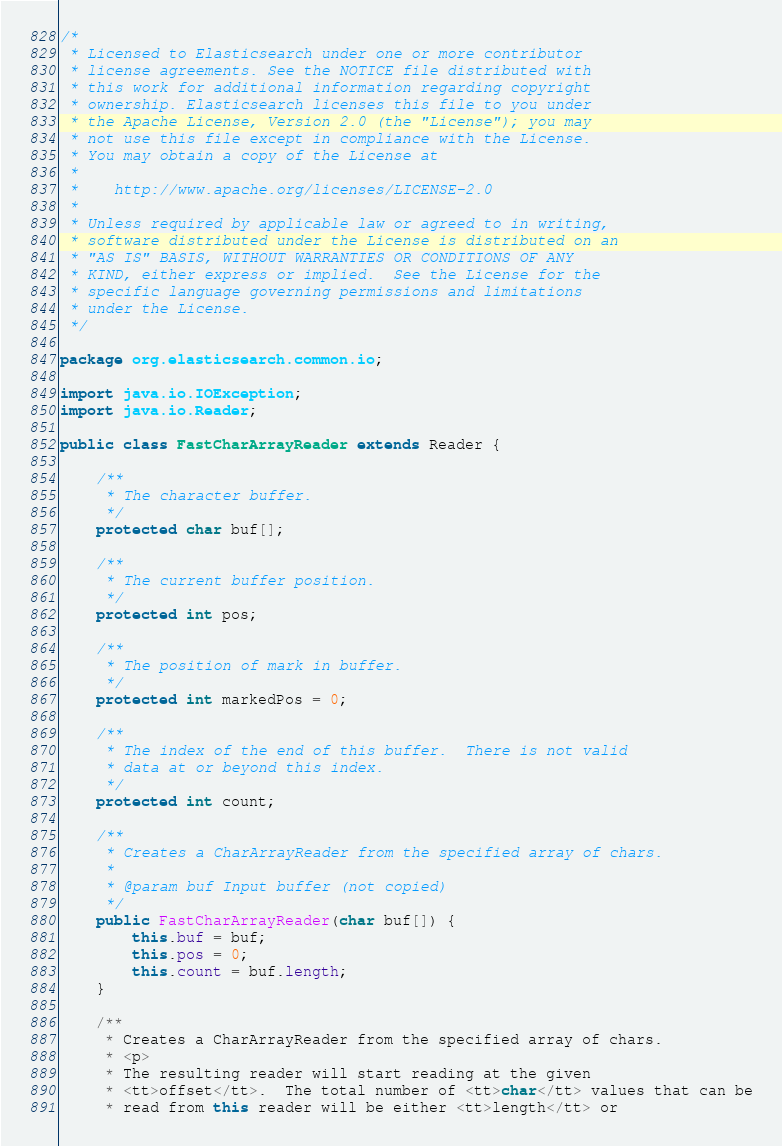Convert code to text. <code><loc_0><loc_0><loc_500><loc_500><_Java_>/*
 * Licensed to Elasticsearch under one or more contributor
 * license agreements. See the NOTICE file distributed with
 * this work for additional information regarding copyright
 * ownership. Elasticsearch licenses this file to you under
 * the Apache License, Version 2.0 (the "License"); you may
 * not use this file except in compliance with the License.
 * You may obtain a copy of the License at
 *
 *    http://www.apache.org/licenses/LICENSE-2.0
 *
 * Unless required by applicable law or agreed to in writing,
 * software distributed under the License is distributed on an
 * "AS IS" BASIS, WITHOUT WARRANTIES OR CONDITIONS OF ANY
 * KIND, either express or implied.  See the License for the
 * specific language governing permissions and limitations
 * under the License.
 */

package org.elasticsearch.common.io;

import java.io.IOException;
import java.io.Reader;

public class FastCharArrayReader extends Reader {

    /**
     * The character buffer.
     */
    protected char buf[];

    /**
     * The current buffer position.
     */
    protected int pos;

    /**
     * The position of mark in buffer.
     */
    protected int markedPos = 0;

    /**
     * The index of the end of this buffer.  There is not valid
     * data at or beyond this index.
     */
    protected int count;

    /**
     * Creates a CharArrayReader from the specified array of chars.
     *
     * @param buf Input buffer (not copied)
     */
    public FastCharArrayReader(char buf[]) {
        this.buf = buf;
        this.pos = 0;
        this.count = buf.length;
    }

    /**
     * Creates a CharArrayReader from the specified array of chars.
     * <p>
     * The resulting reader will start reading at the given
     * <tt>offset</tt>.  The total number of <tt>char</tt> values that can be
     * read from this reader will be either <tt>length</tt> or</code> 